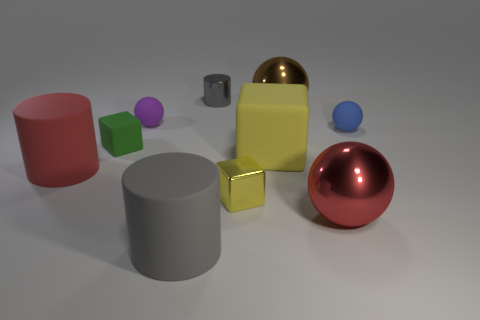There is a shiny cube that is the same color as the big matte cube; what size is it?
Your answer should be very brief. Small. What number of other cylinders are the same color as the small shiny cylinder?
Keep it short and to the point. 1. How many things are either blue objects or rubber balls?
Your response must be concise. 2. There is a metallic sphere that is behind the tiny yellow cube; what is its color?
Ensure brevity in your answer.  Brown. The brown thing that is the same shape as the small blue object is what size?
Your answer should be very brief. Large. What number of things are large objects on the left side of the brown thing or blocks that are to the left of the tiny yellow thing?
Provide a succinct answer. 4. What is the size of the cylinder that is to the right of the small purple rubber object and in front of the brown object?
Provide a succinct answer. Large. Does the gray rubber object have the same shape as the large red thing left of the big block?
Your answer should be compact. Yes. What number of objects are either red rubber objects that are in front of the small gray metallic thing or green matte spheres?
Offer a very short reply. 1. Is the big red ball made of the same material as the gray cylinder behind the brown thing?
Offer a very short reply. Yes. 